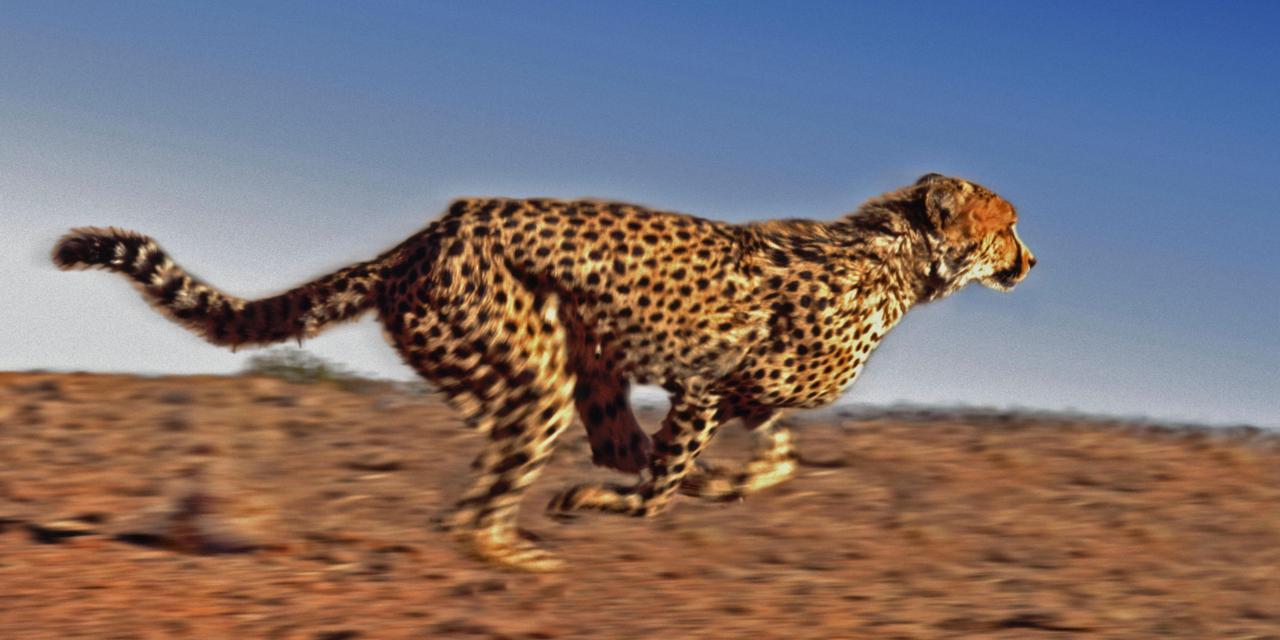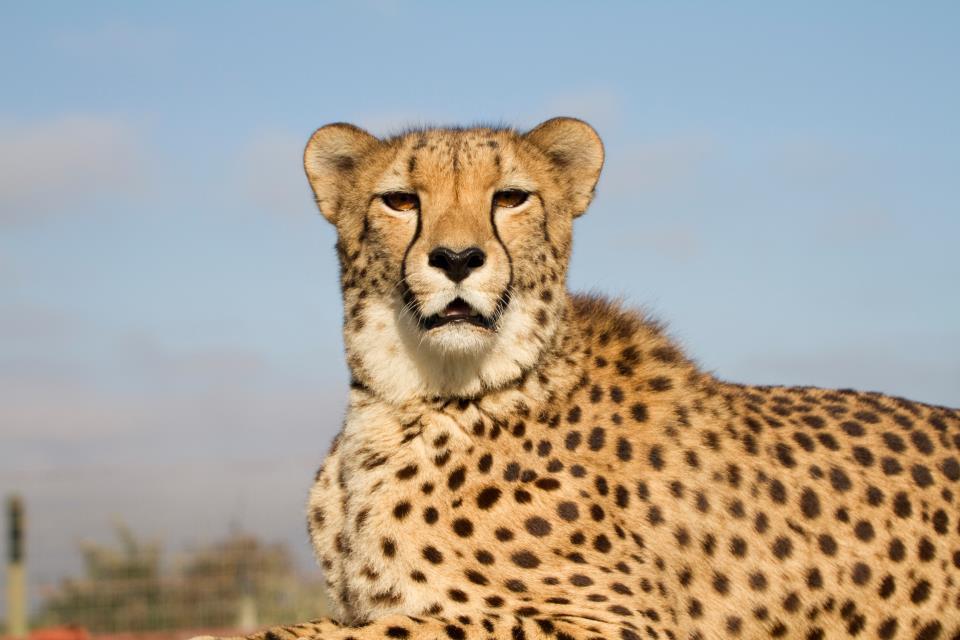The first image is the image on the left, the second image is the image on the right. Examine the images to the left and right. Is the description "Cheetahs are alone, without children, and not running." accurate? Answer yes or no. No. 